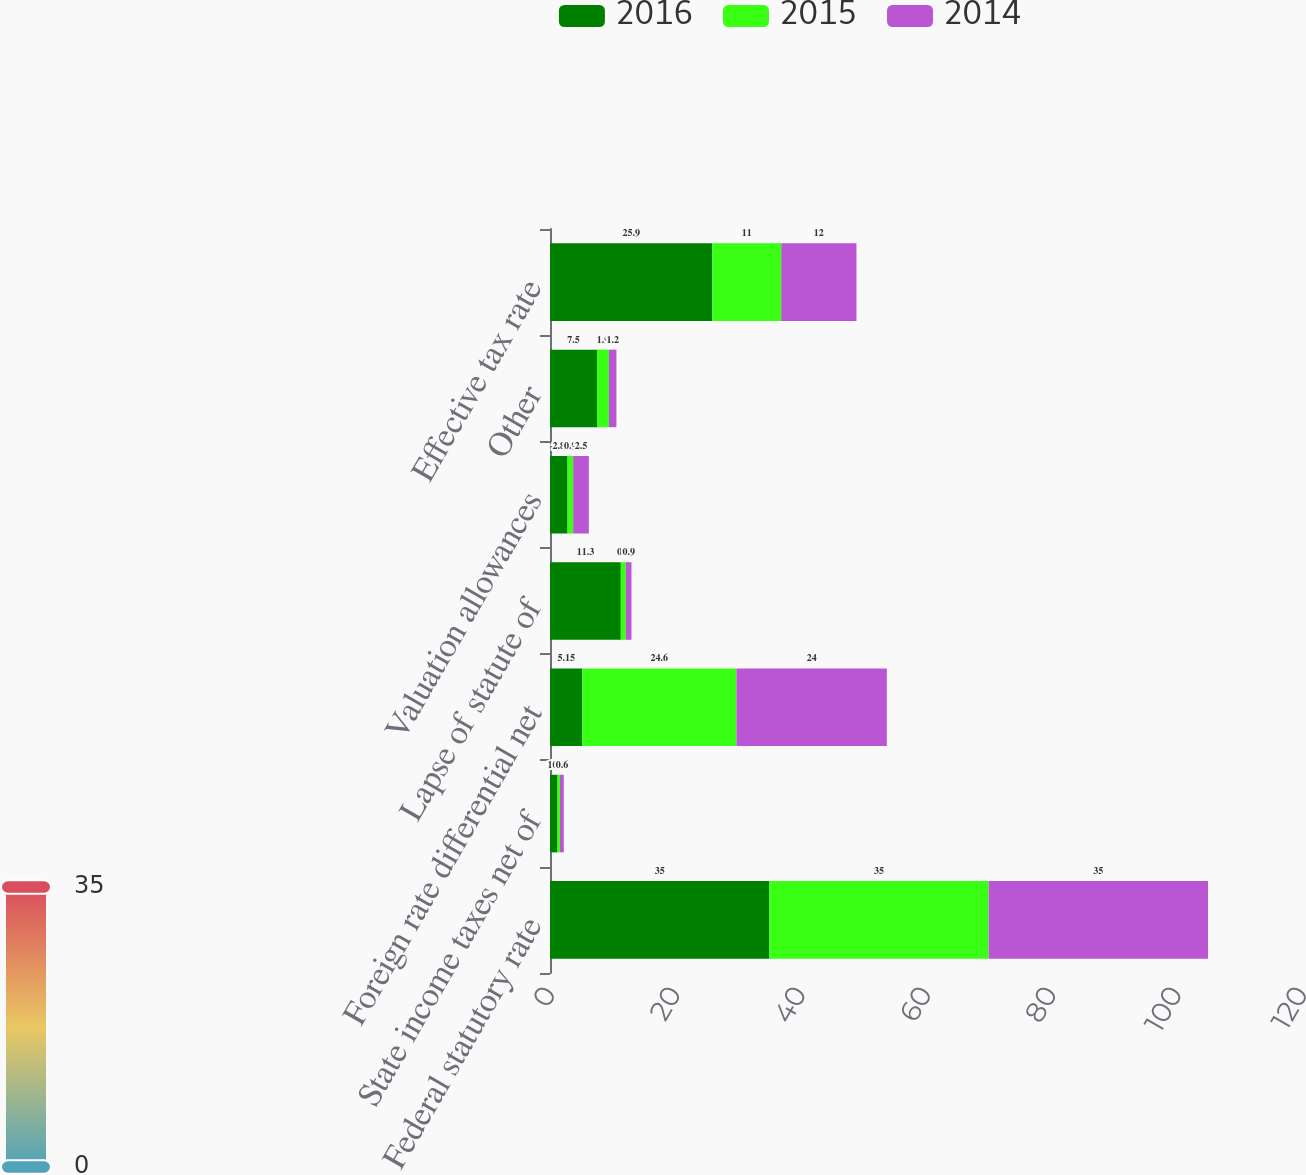<chart> <loc_0><loc_0><loc_500><loc_500><stacked_bar_chart><ecel><fcel>Federal statutory rate<fcel>State income taxes net of<fcel>Foreign rate differential net<fcel>Lapse of statute of<fcel>Valuation allowances<fcel>Other<fcel>Effective tax rate<nl><fcel>2016<fcel>35<fcel>1.2<fcel>5.15<fcel>11.3<fcel>2.8<fcel>7.5<fcel>25.9<nl><fcel>2015<fcel>35<fcel>0.4<fcel>24.6<fcel>0.8<fcel>0.9<fcel>1.9<fcel>11<nl><fcel>2014<fcel>35<fcel>0.6<fcel>24<fcel>0.9<fcel>2.5<fcel>1.2<fcel>12<nl></chart> 